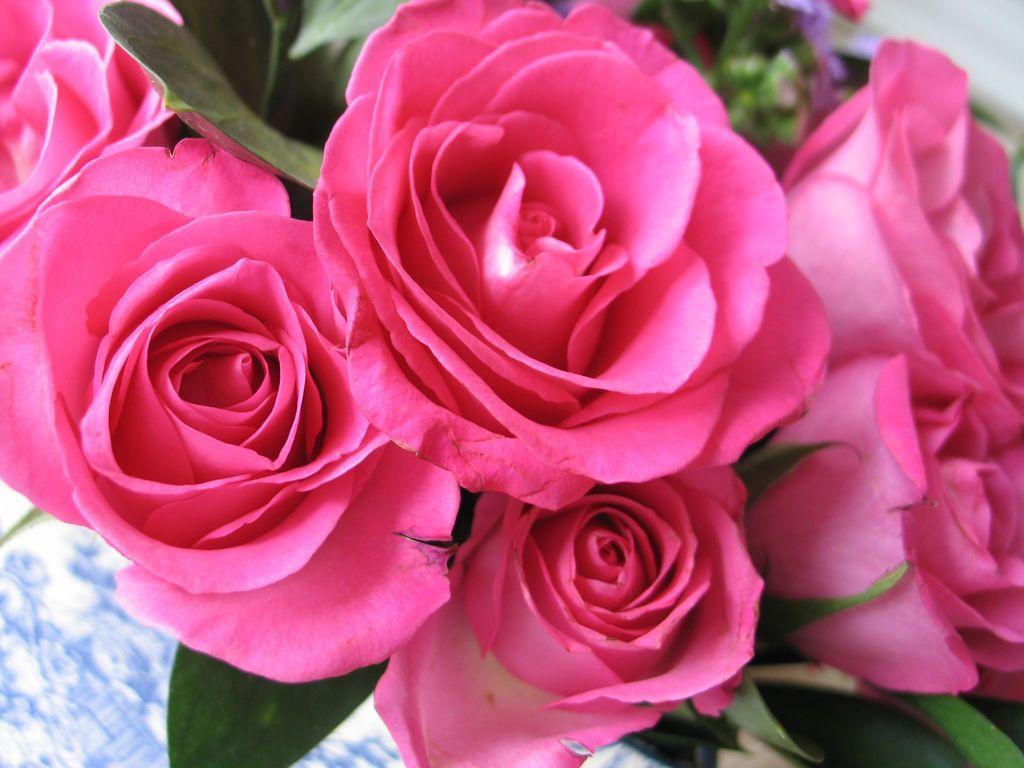Could you give a brief overview of what you see in this image? In the image there are beautiful pink roses. 